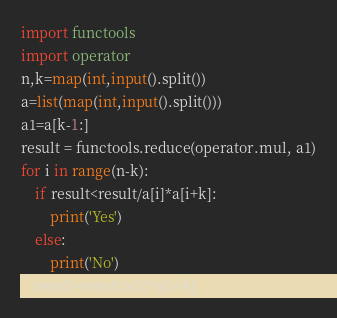Convert code to text. <code><loc_0><loc_0><loc_500><loc_500><_Python_>import functools
import operator
n,k=map(int,input().split())
a=list(map(int,input().split()))
a1=a[k-1:]
result = functools.reduce(operator.mul, a1)
for i in range(n-k):
    if result<result/a[i]*a[i+k]:
        print('Yes')
    else:
        print('No')
    result=result/a[i]*a[i+k]</code> 